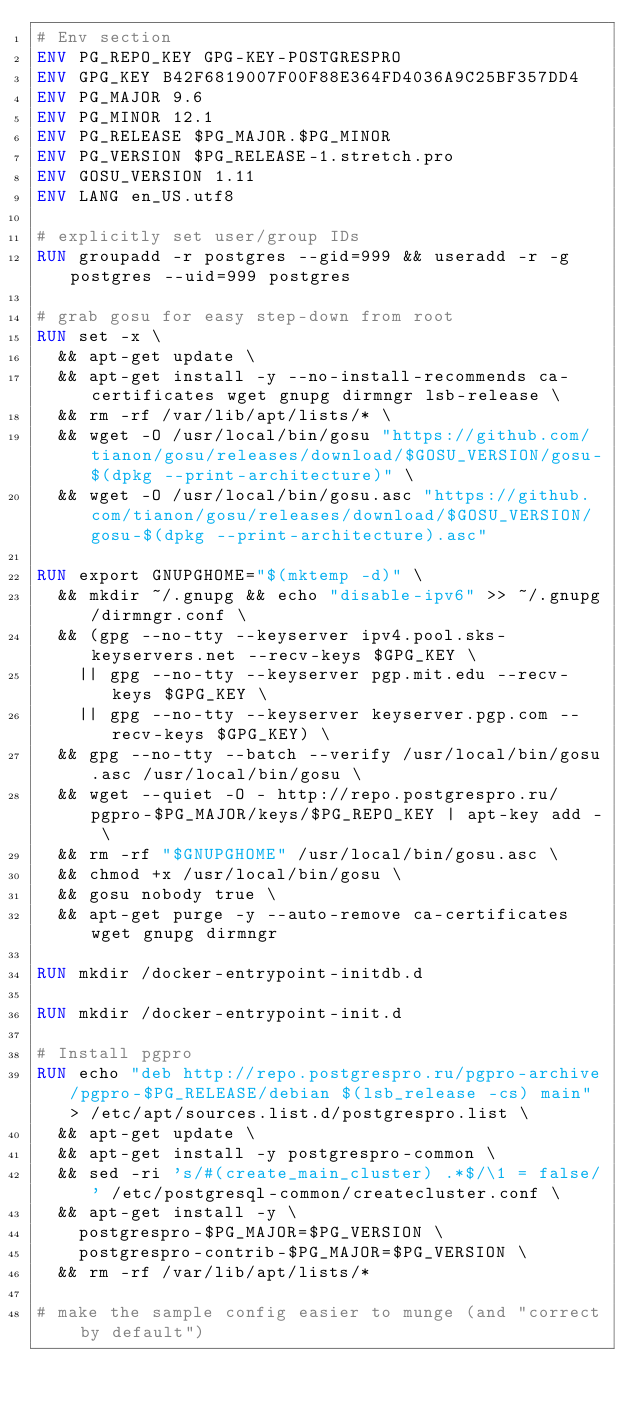Convert code to text. <code><loc_0><loc_0><loc_500><loc_500><_Dockerfile_># Env section
ENV PG_REPO_KEY GPG-KEY-POSTGRESPRO
ENV GPG_KEY B42F6819007F00F88E364FD4036A9C25BF357DD4
ENV PG_MAJOR 9.6
ENV PG_MINOR 12.1
ENV PG_RELEASE $PG_MAJOR.$PG_MINOR
ENV PG_VERSION $PG_RELEASE-1.stretch.pro
ENV GOSU_VERSION 1.11
ENV LANG en_US.utf8

# explicitly set user/group IDs
RUN groupadd -r postgres --gid=999 && useradd -r -g postgres --uid=999 postgres

# grab gosu for easy step-down from root
RUN set -x \
	&& apt-get update \
	&& apt-get install -y --no-install-recommends ca-certificates wget gnupg dirmngr lsb-release \
	&& rm -rf /var/lib/apt/lists/* \
	&& wget -O /usr/local/bin/gosu "https://github.com/tianon/gosu/releases/download/$GOSU_VERSION/gosu-$(dpkg --print-architecture)" \
	&& wget -O /usr/local/bin/gosu.asc "https://github.com/tianon/gosu/releases/download/$GOSU_VERSION/gosu-$(dpkg --print-architecture).asc"

RUN export GNUPGHOME="$(mktemp -d)" \
	&& mkdir ~/.gnupg && echo "disable-ipv6" >> ~/.gnupg/dirmngr.conf \
	&& (gpg --no-tty --keyserver ipv4.pool.sks-keyservers.net --recv-keys $GPG_KEY \
		|| gpg --no-tty --keyserver pgp.mit.edu --recv-keys $GPG_KEY \
		|| gpg --no-tty --keyserver keyserver.pgp.com --recv-keys $GPG_KEY) \
	&& gpg --no-tty --batch --verify /usr/local/bin/gosu.asc /usr/local/bin/gosu \
	&& wget --quiet -O - http://repo.postgrespro.ru/pgpro-$PG_MAJOR/keys/$PG_REPO_KEY | apt-key add - \
	&& rm -rf "$GNUPGHOME" /usr/local/bin/gosu.asc \
	&& chmod +x /usr/local/bin/gosu \
	&& gosu nobody true \
	&& apt-get purge -y --auto-remove ca-certificates wget gnupg dirmngr

RUN mkdir /docker-entrypoint-initdb.d

RUN mkdir /docker-entrypoint-init.d

# Install pgpro
RUN echo "deb http://repo.postgrespro.ru/pgpro-archive/pgpro-$PG_RELEASE/debian $(lsb_release -cs) main" > /etc/apt/sources.list.d/postgrespro.list \
	&& apt-get update \
	&& apt-get install -y postgrespro-common \
	&& sed -ri 's/#(create_main_cluster) .*$/\1 = false/' /etc/postgresql-common/createcluster.conf \
	&& apt-get install -y \
		postgrespro-$PG_MAJOR=$PG_VERSION \
		postgrespro-contrib-$PG_MAJOR=$PG_VERSION \
	&& rm -rf /var/lib/apt/lists/*

# make the sample config easier to munge (and "correct by default")</code> 